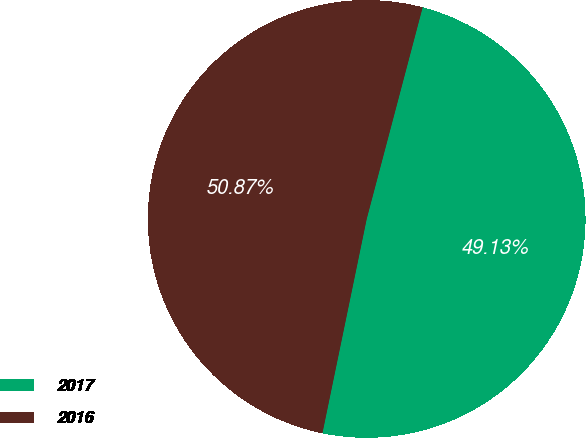Convert chart to OTSL. <chart><loc_0><loc_0><loc_500><loc_500><pie_chart><fcel>2017<fcel>2016<nl><fcel>49.13%<fcel>50.87%<nl></chart> 